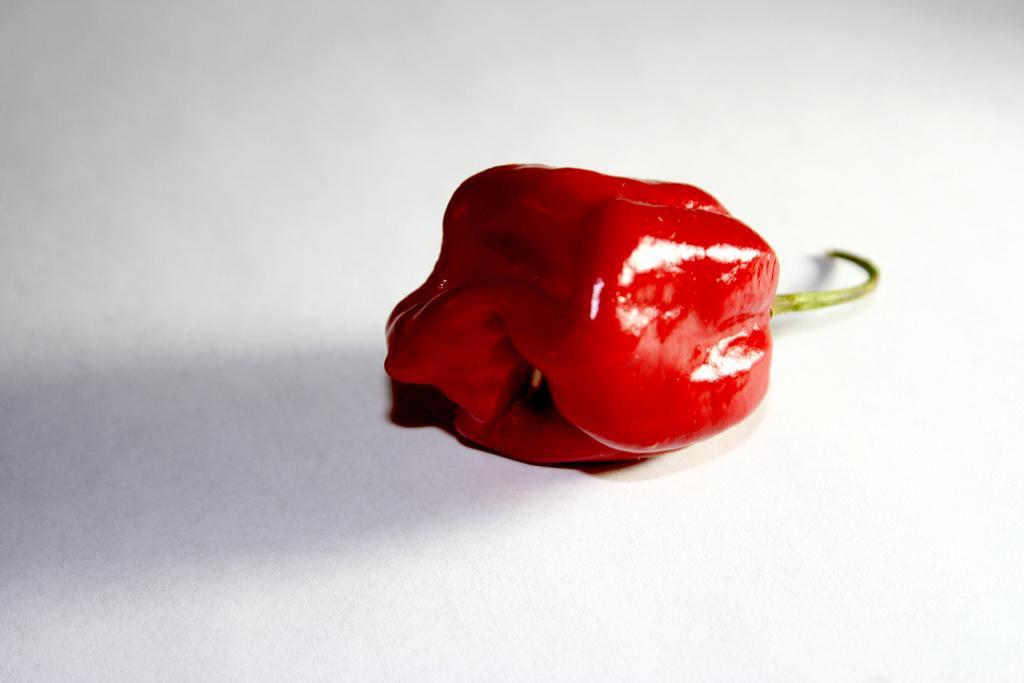How would you summarize this image in a sentence or two? In this image, we can see red capsicum on the white surface. 